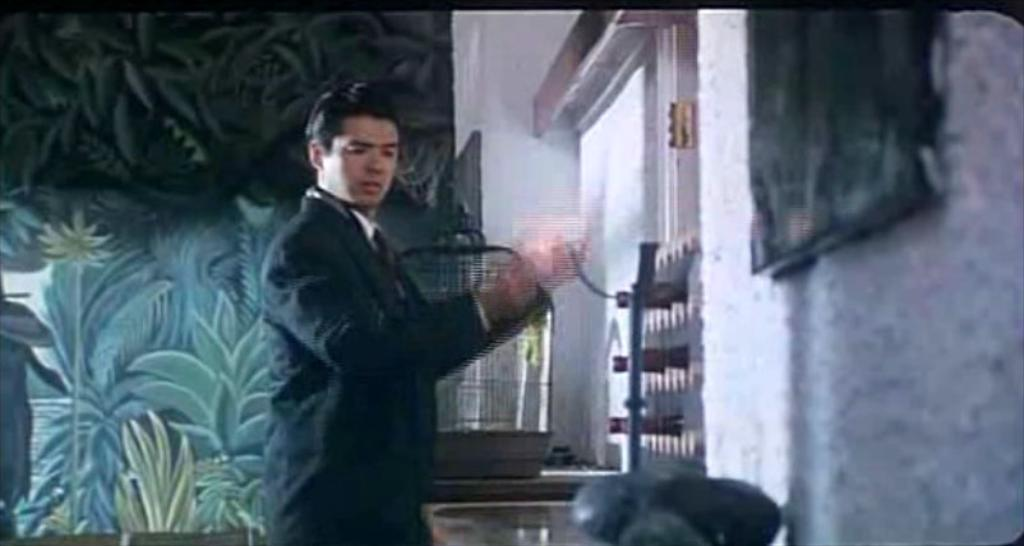What is the main subject of the image? There is a man standing in the image. Where is the man standing? The man is standing on a path. What can be seen in the image besides the man? There is a cage on an object in the image. What is visible in the background of the image? There is a wall visible in the background of the image. What type of hair is the man wearing in the image? The man is not wearing any hair in the image; he is bald. What kind of toys can be seen in the image? There are no toys present in the image. 